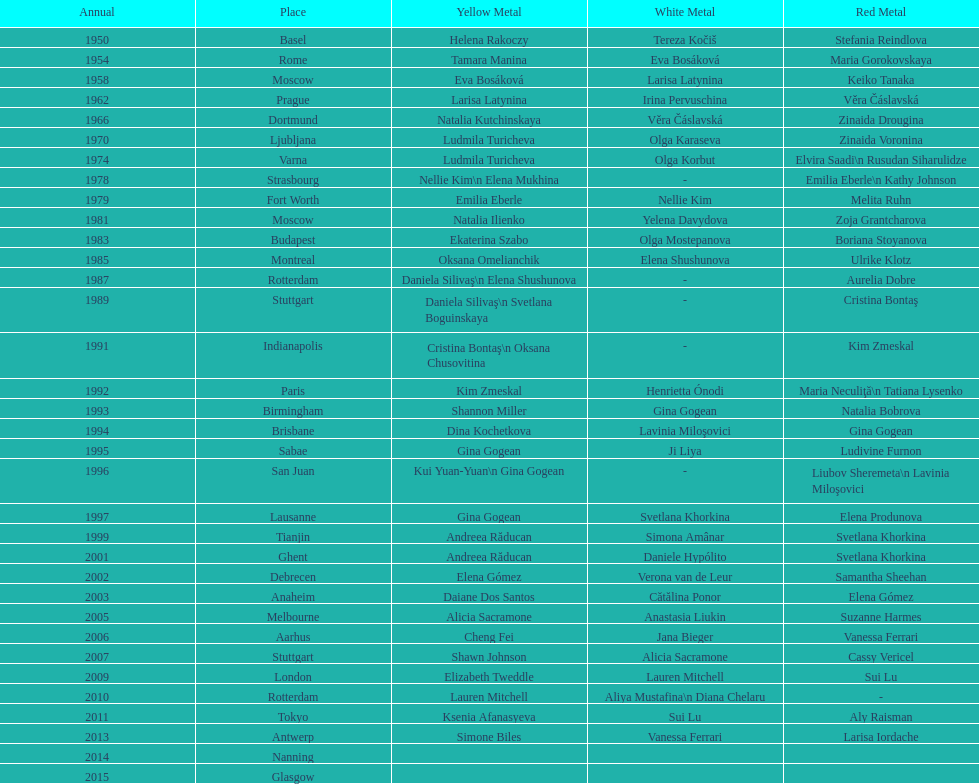How many consecutive floor exercise gold medals did romanian star andreea raducan win at the world championships? 2. 